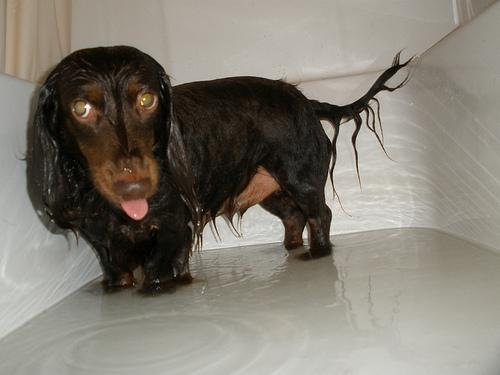How many dogs are in the picture?
Give a very brief answer. 1. 